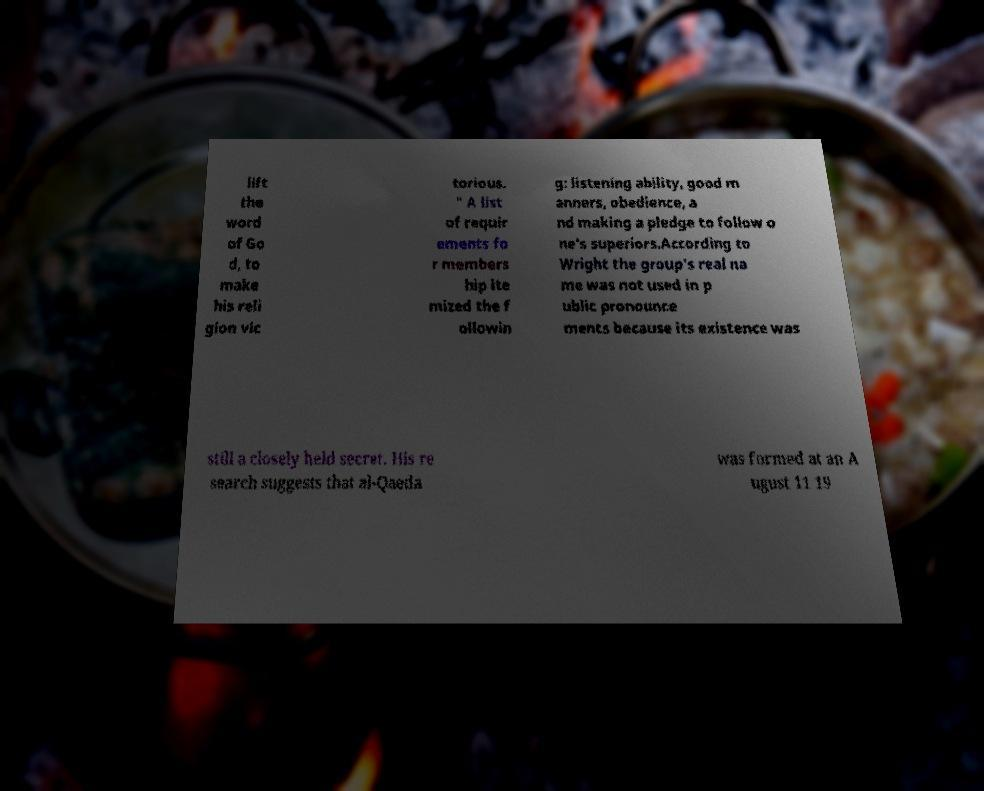There's text embedded in this image that I need extracted. Can you transcribe it verbatim? lift the word of Go d, to make his reli gion vic torious. " A list of requir ements fo r members hip ite mized the f ollowin g: listening ability, good m anners, obedience, a nd making a pledge to follow o ne's superiors.According to Wright the group's real na me was not used in p ublic pronounce ments because its existence was still a closely held secret. His re search suggests that al-Qaeda was formed at an A ugust 11 19 